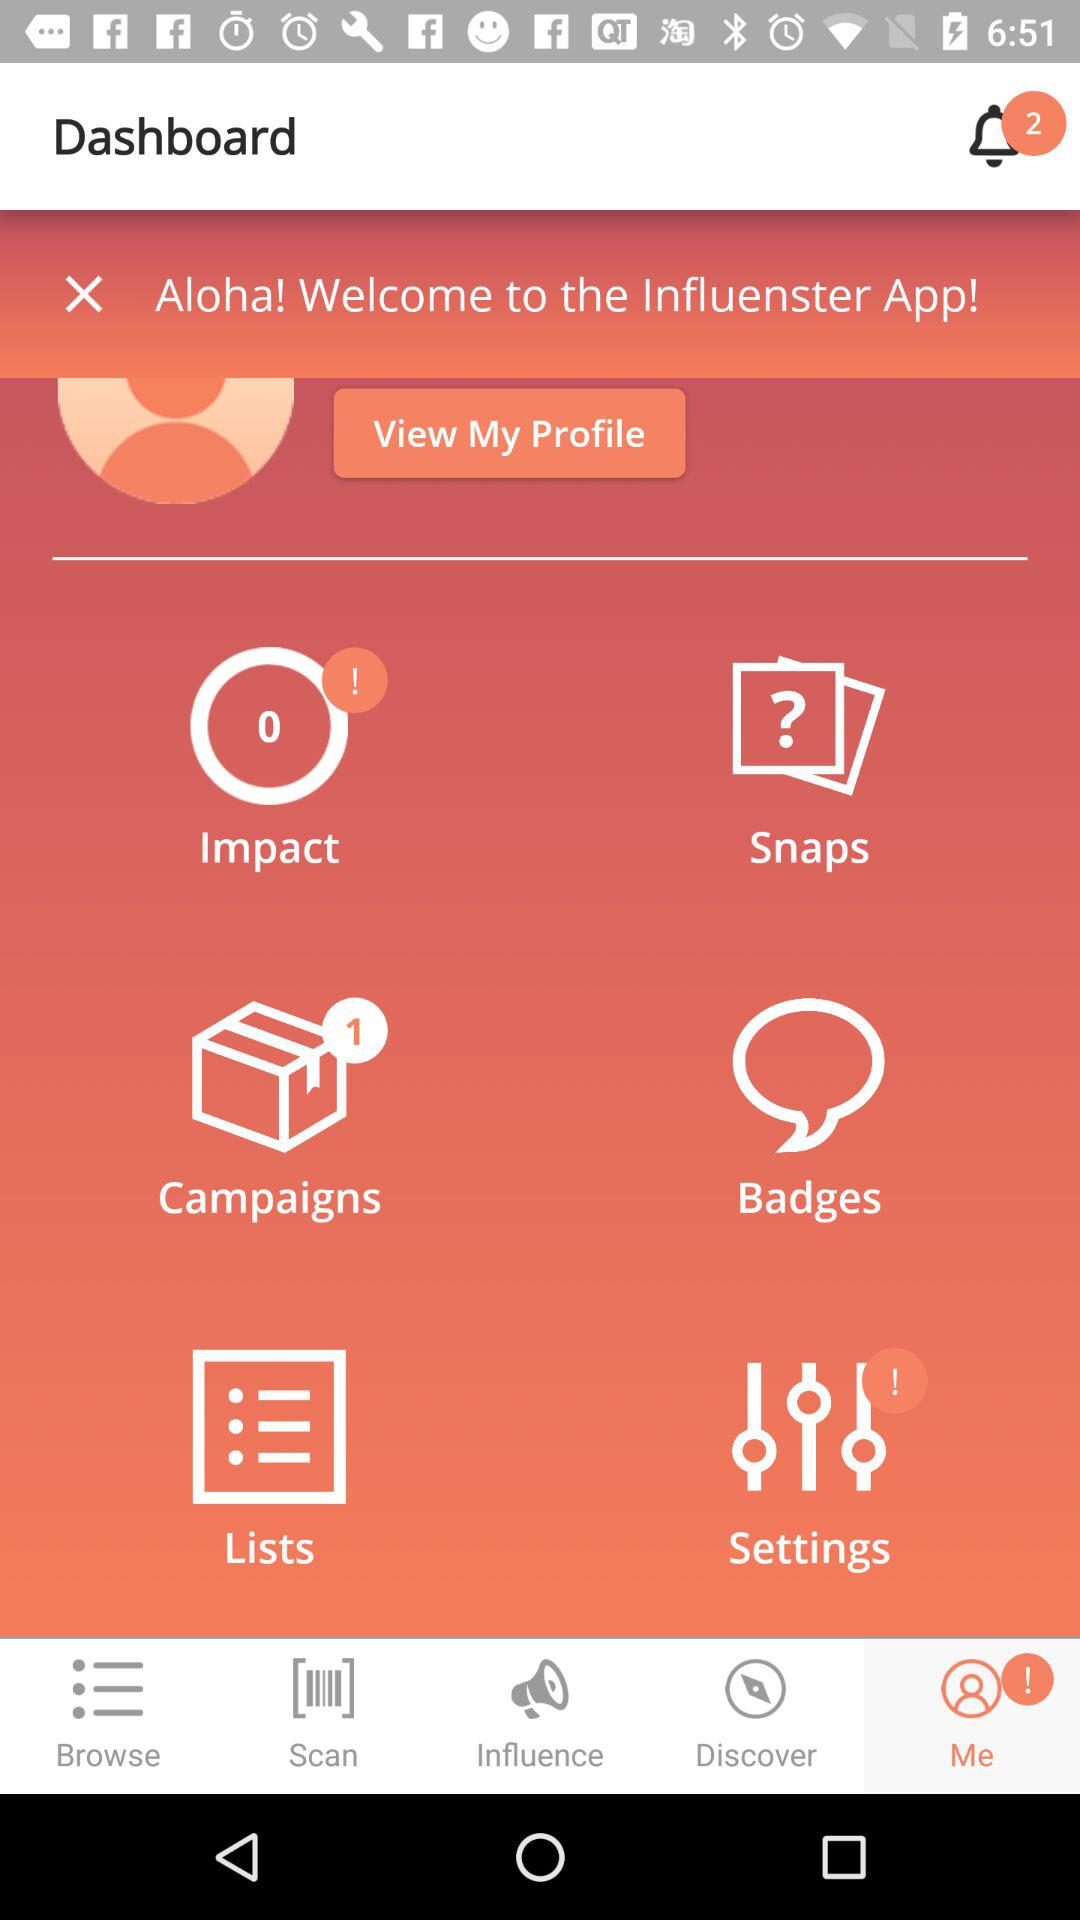How many notifications are there? There are 2 notifications. 